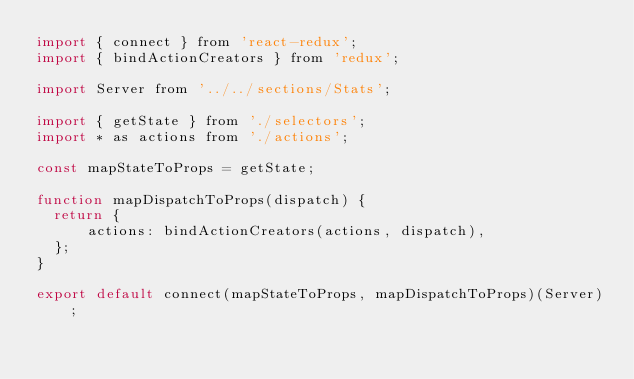Convert code to text. <code><loc_0><loc_0><loc_500><loc_500><_JavaScript_>import { connect } from 'react-redux';
import { bindActionCreators } from 'redux';

import Server from '../../sections/Stats';

import { getState } from './selectors';
import * as actions from './actions';

const mapStateToProps = getState;

function mapDispatchToProps(dispatch) {
  return {
      actions: bindActionCreators(actions, dispatch),
  };
}

export default connect(mapStateToProps, mapDispatchToProps)(Server);
</code> 